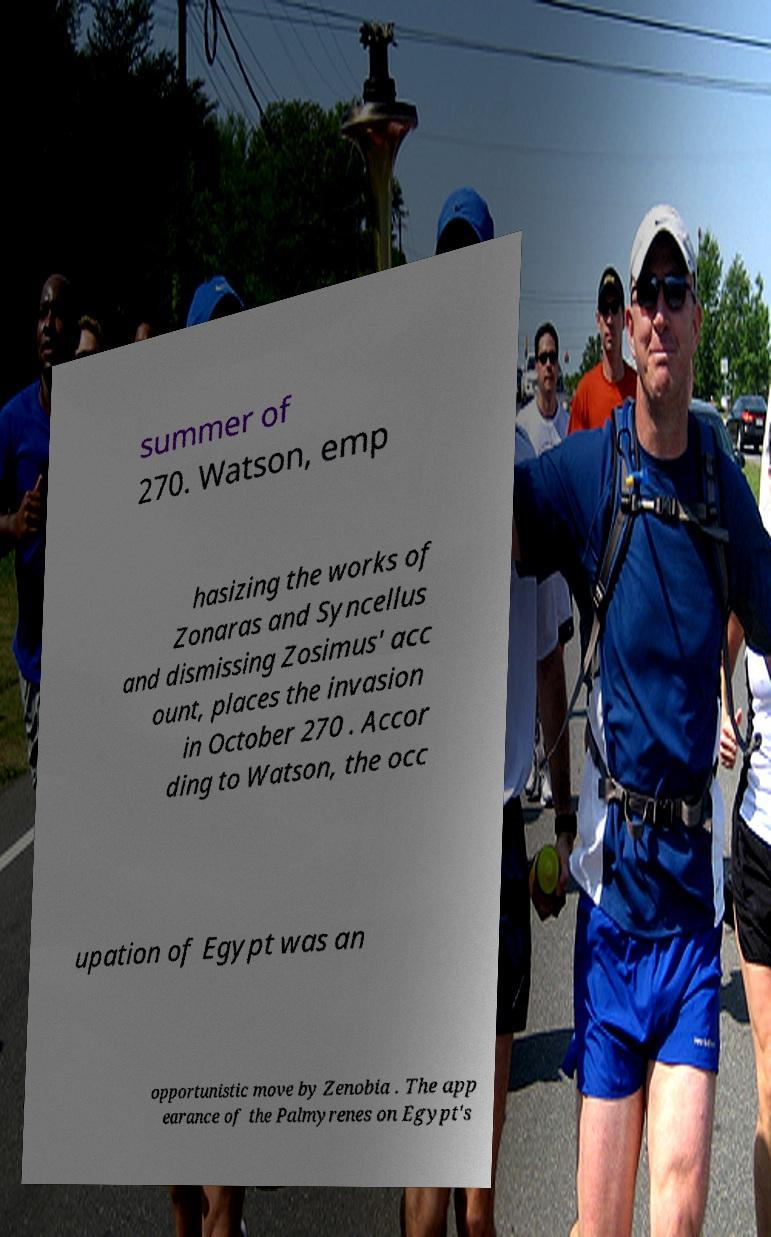Please identify and transcribe the text found in this image. summer of 270. Watson, emp hasizing the works of Zonaras and Syncellus and dismissing Zosimus' acc ount, places the invasion in October 270 . Accor ding to Watson, the occ upation of Egypt was an opportunistic move by Zenobia . The app earance of the Palmyrenes on Egypt's 